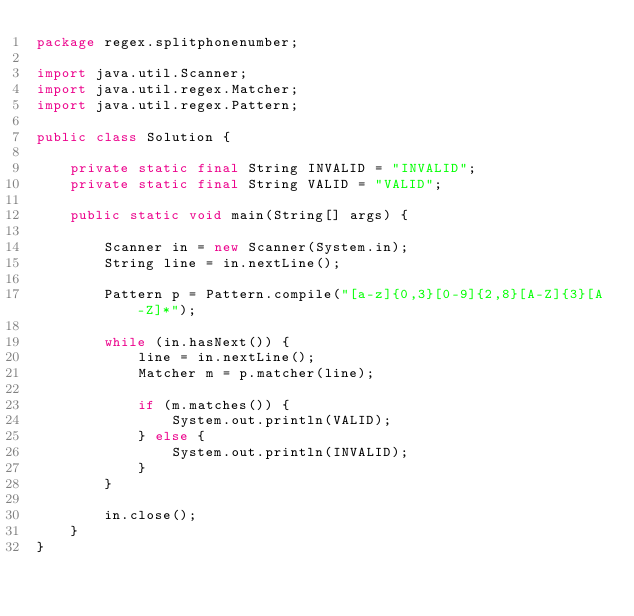Convert code to text. <code><loc_0><loc_0><loc_500><loc_500><_Java_>package regex.splitphonenumber;

import java.util.Scanner;
import java.util.regex.Matcher;
import java.util.regex.Pattern;

public class Solution {

	private static final String INVALID = "INVALID";
	private static final String VALID = "VALID";

	public static void main(String[] args) {

		Scanner in = new Scanner(System.in);
		String line = in.nextLine();

		Pattern p = Pattern.compile("[a-z]{0,3}[0-9]{2,8}[A-Z]{3}[A-Z]*");

		while (in.hasNext()) {
			line = in.nextLine();
			Matcher m = p.matcher(line);

			if (m.matches()) {
				System.out.println(VALID);
			} else {
				System.out.println(INVALID);
			}
		}

		in.close();
	}
}</code> 